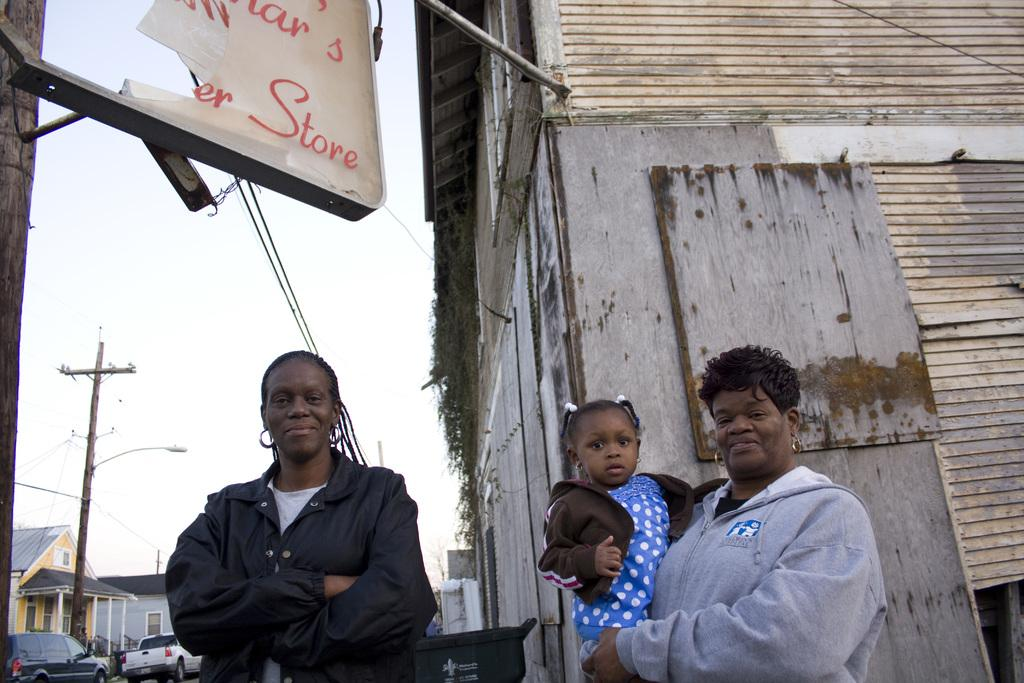How many people are in the image? There are two persons in the image. What is one person doing with the kid? One person is holding a kid. What can be seen in the background of the image? There are houses, poles, wires, vehicles, a board, and the sky visible in the background of the image. What type of sheet is being used to cover the shop in the image? There is no sheet or shop present in the image. What kind of work is being done on the board in the image? There is no work being done on the board in the image; it is just visible in the background. 